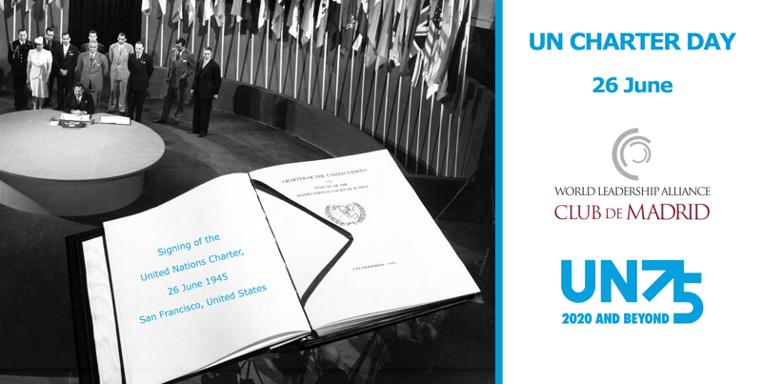What date is UN Charter Day celebrated? UN Charter Day is celebrated on 26th June each year to commemorate the signing of the United Nations Charter, which laid the foundation for the establishment of the United Nations, aiming to maintain international peace and security. 